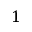<formula> <loc_0><loc_0><loc_500><loc_500>1</formula> 